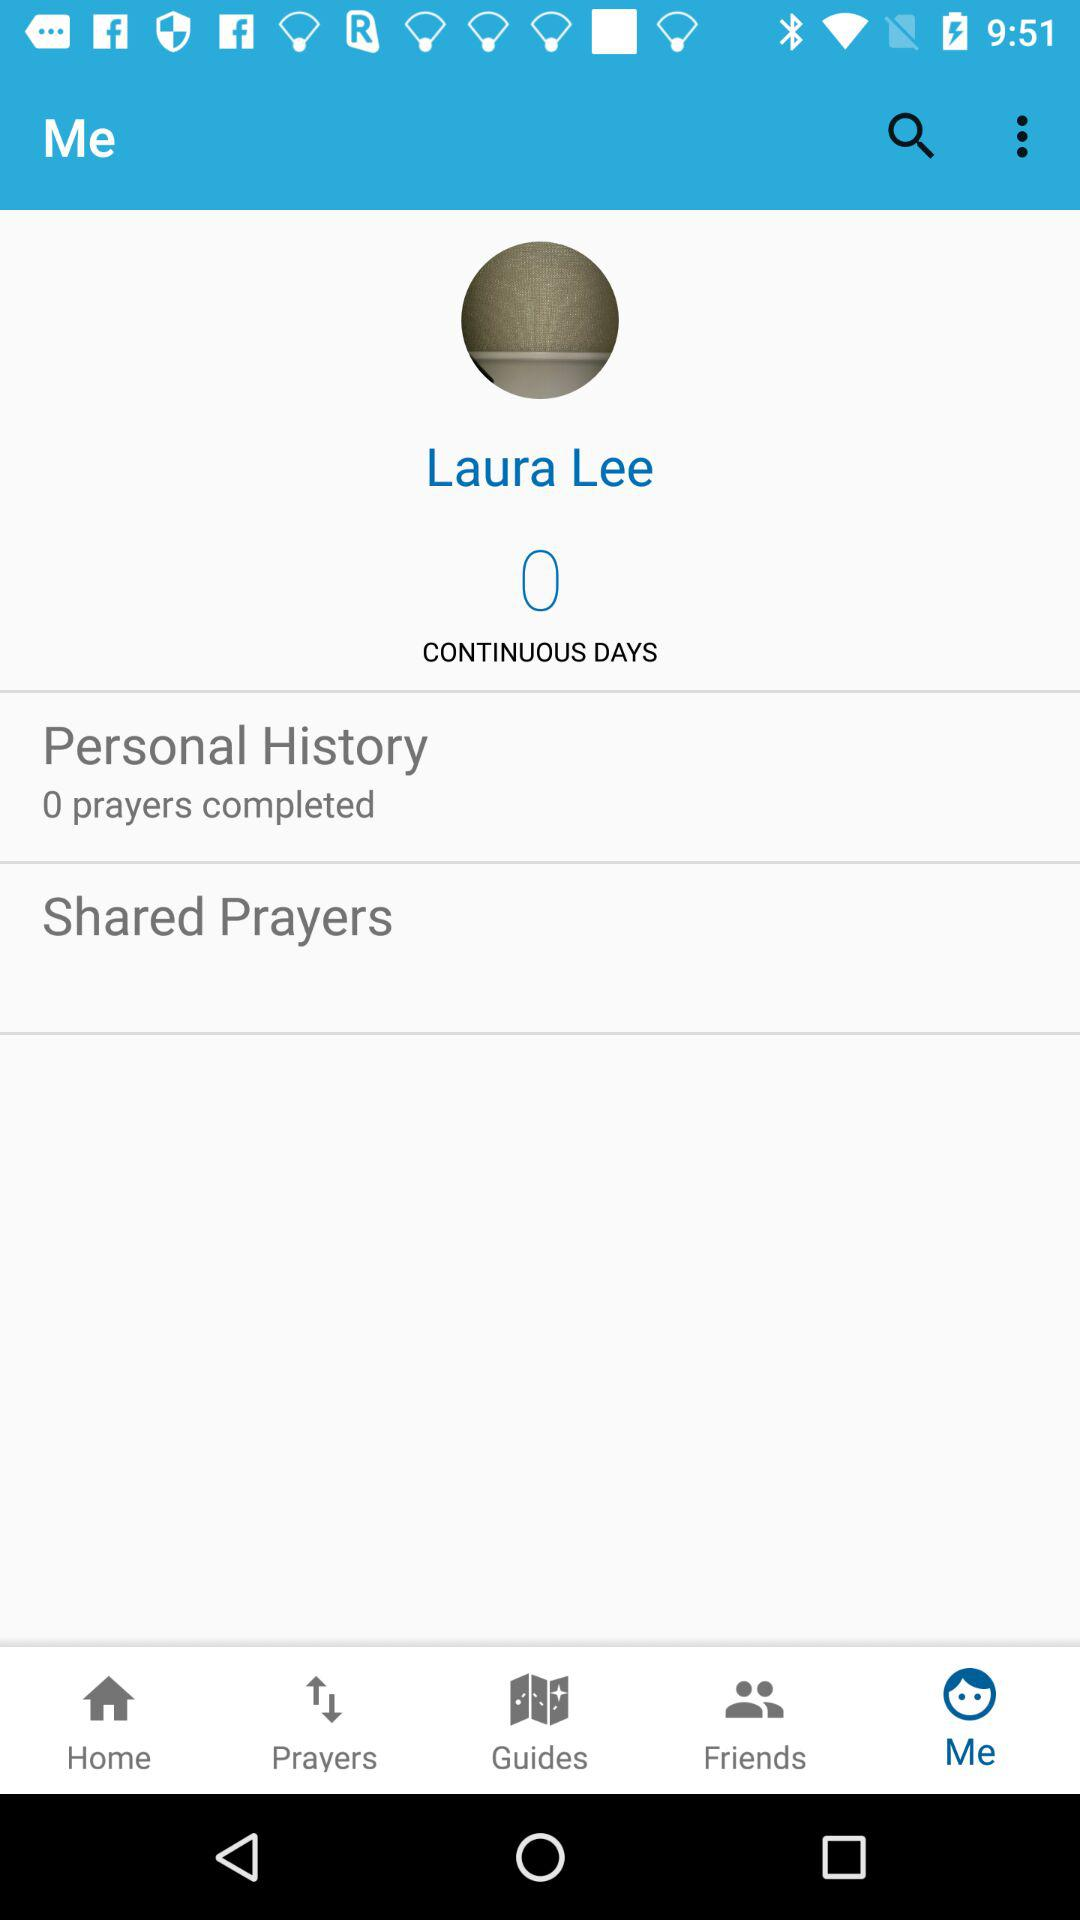How many prayers have been completed? There are 0 prayers completed. 